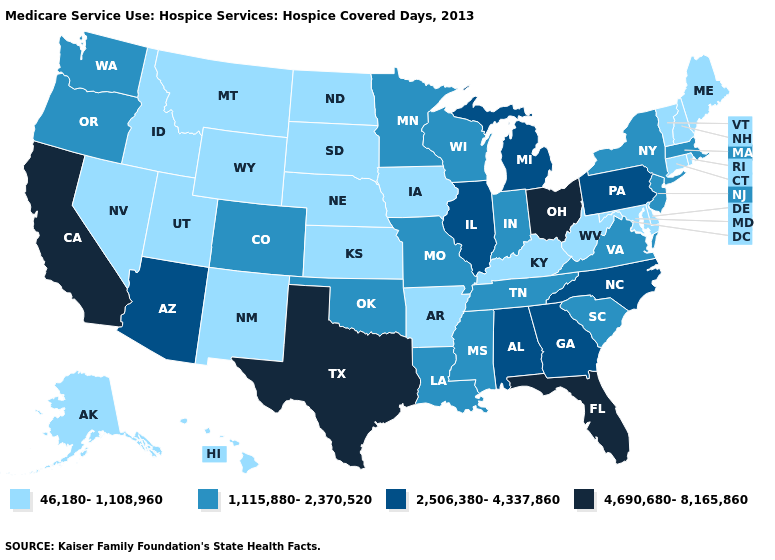What is the value of Hawaii?
Give a very brief answer. 46,180-1,108,960. Name the states that have a value in the range 2,506,380-4,337,860?
Write a very short answer. Alabama, Arizona, Georgia, Illinois, Michigan, North Carolina, Pennsylvania. Name the states that have a value in the range 1,115,880-2,370,520?
Concise answer only. Colorado, Indiana, Louisiana, Massachusetts, Minnesota, Mississippi, Missouri, New Jersey, New York, Oklahoma, Oregon, South Carolina, Tennessee, Virginia, Washington, Wisconsin. Which states hav the highest value in the South?
Answer briefly. Florida, Texas. How many symbols are there in the legend?
Give a very brief answer. 4. Is the legend a continuous bar?
Answer briefly. No. What is the value of Oregon?
Concise answer only. 1,115,880-2,370,520. What is the lowest value in the USA?
Concise answer only. 46,180-1,108,960. Name the states that have a value in the range 46,180-1,108,960?
Concise answer only. Alaska, Arkansas, Connecticut, Delaware, Hawaii, Idaho, Iowa, Kansas, Kentucky, Maine, Maryland, Montana, Nebraska, Nevada, New Hampshire, New Mexico, North Dakota, Rhode Island, South Dakota, Utah, Vermont, West Virginia, Wyoming. Name the states that have a value in the range 46,180-1,108,960?
Answer briefly. Alaska, Arkansas, Connecticut, Delaware, Hawaii, Idaho, Iowa, Kansas, Kentucky, Maine, Maryland, Montana, Nebraska, Nevada, New Hampshire, New Mexico, North Dakota, Rhode Island, South Dakota, Utah, Vermont, West Virginia, Wyoming. What is the value of Colorado?
Be succinct. 1,115,880-2,370,520. What is the highest value in the MidWest ?
Give a very brief answer. 4,690,680-8,165,860. Name the states that have a value in the range 4,690,680-8,165,860?
Be succinct. California, Florida, Ohio, Texas. Which states hav the highest value in the West?
Give a very brief answer. California. 